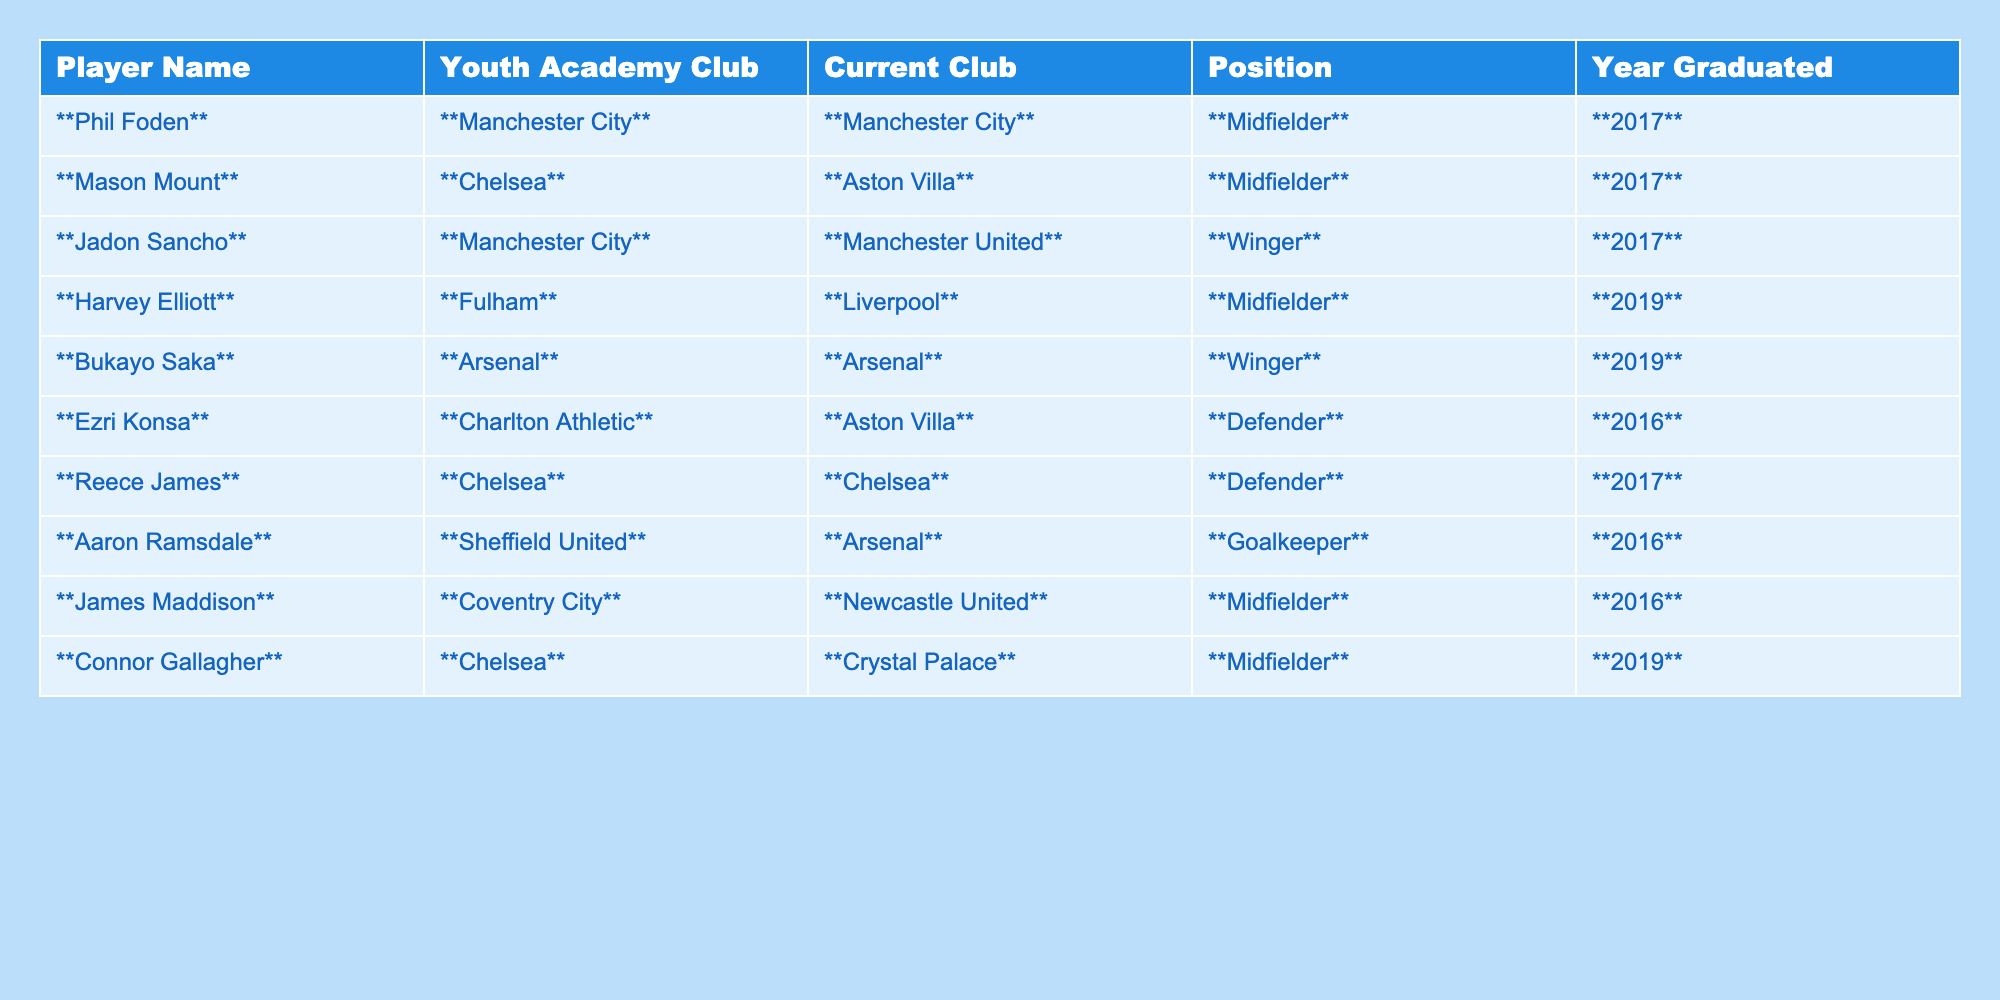What year did Phil Foden graduate from the youth academy? The table states that Phil Foden graduated in 2017.
Answer: 2017 Which player listed in the table is currently playing for Arsenal? The table indicates that Bukayo Saka and Aaron Ramsdale are both current players for Arsenal.
Answer: Bukayo Saka and Aaron Ramsdale How many players in the table graduated in 2019? There are two players listed under the Year Graduated column for 2019: Harvey Elliott and Connor Gallagher.
Answer: 2 Did any players graduate from Chelsea and still play for Chelsea? The table shows that Reece James graduated from Chelsea and is still playing for Chelsea. Therefore, the answer is yes.
Answer: Yes Which current club has the most graduates listed in the table? By counting the Current Club column, Chelsea has three players (Mason Mount, Reece James, Connor Gallagher), while Arsenal has two, and other clubs have one or none. Therefore, Chelsea has the most graduates.
Answer: Chelsea Is there a player listed who plays as a winger and is a current player for Manchester United? The table lists Jadon Sancho as a current player for Manchester United and he plays as a winger.
Answer: Yes What is the difference in the number of years graduated between the youngest and oldest graduates in the table? The oldest players (Ezri Konsa and Ramsdale) graduated in 2016, while the youngest (Harvey Elliott and Connor Gallagher) graduated in 2019. The difference in years is 2019 - 2016 = 3 years.
Answer: 3 years How many players from Chelsea graduated in the same year, and what are their names? Mason Mount and Reece James both graduated from Chelsea in 2017, so they graduated in the same year.
Answer: 2 graduates: Mason Mount and Reece James Which position is the most common among the players currently listed? By examining the Positions of the players, there are four midfielders (Phil Foden, Mason Mount, Harvey Elliott, Connor Gallagher) and three defenders (Ezri Konsa and Reece James), meaning midfielders are the most common.
Answer: Midfielder How many total players are listed in the table from Manchester City? The table shows that there are three players listed who graduated or currently play for Manchester City: Phil Foden, Jadon Sancho, and another mention of Phil Foden for his current club status.
Answer: 2 players 